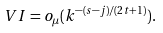Convert formula to latex. <formula><loc_0><loc_0><loc_500><loc_500>V I = o _ { \mu } ( k ^ { - ( s - j ) / ( 2 t + 1 ) } ) .</formula> 